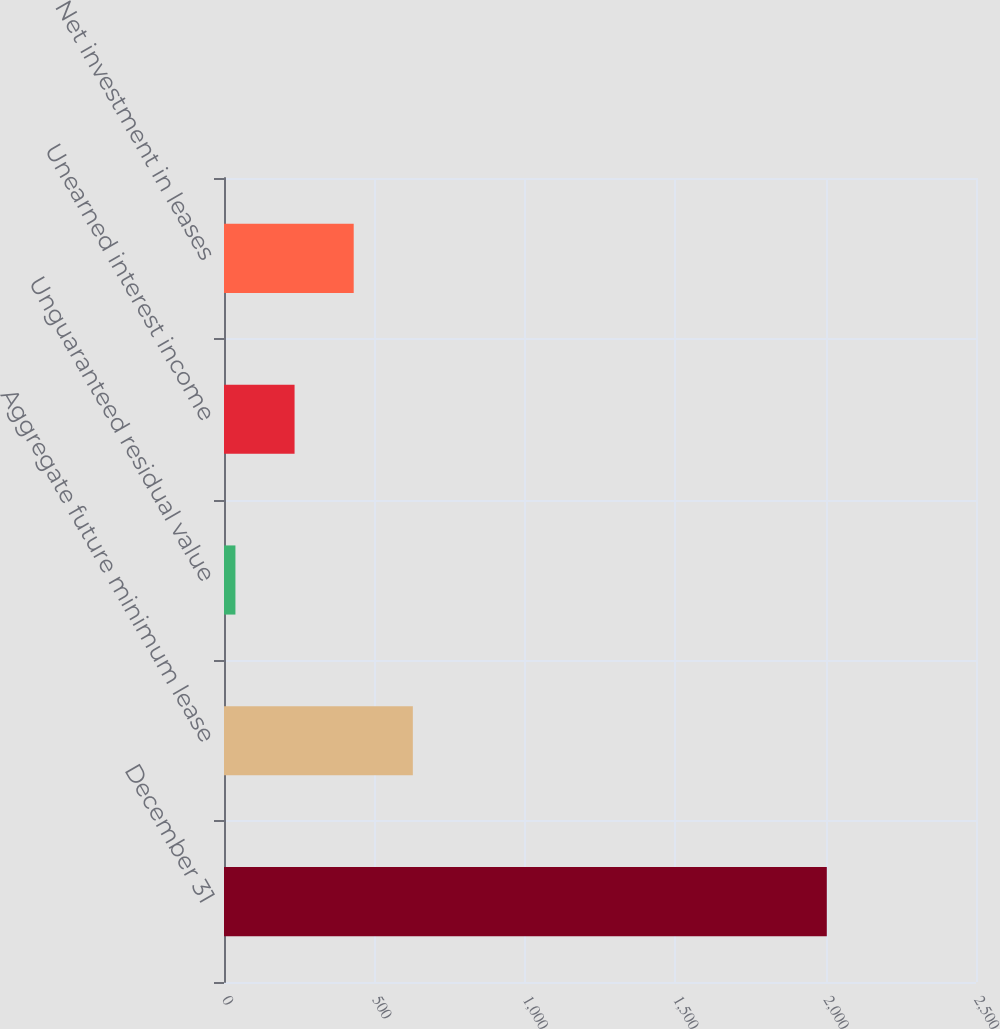Convert chart. <chart><loc_0><loc_0><loc_500><loc_500><bar_chart><fcel>December 31<fcel>Aggregate future minimum lease<fcel>Unguaranteed residual value<fcel>Unearned interest income<fcel>Net investment in leases<nl><fcel>2004<fcel>627.8<fcel>38<fcel>234.6<fcel>431.2<nl></chart> 